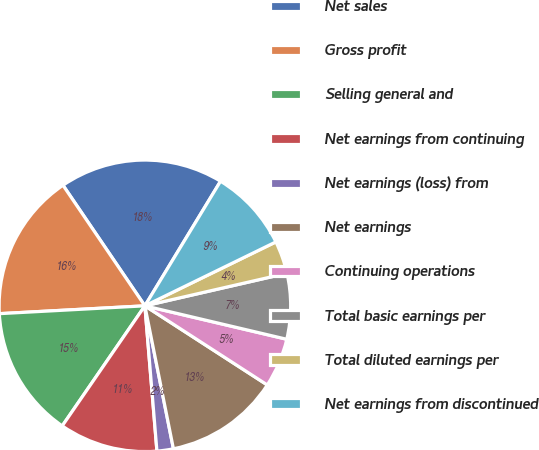<chart> <loc_0><loc_0><loc_500><loc_500><pie_chart><fcel>Net sales<fcel>Gross profit<fcel>Selling general and<fcel>Net earnings from continuing<fcel>Net earnings (loss) from<fcel>Net earnings<fcel>Continuing operations<fcel>Total basic earnings per<fcel>Total diluted earnings per<fcel>Net earnings from discontinued<nl><fcel>18.18%<fcel>16.36%<fcel>14.55%<fcel>10.91%<fcel>1.82%<fcel>12.73%<fcel>5.45%<fcel>7.27%<fcel>3.64%<fcel>9.09%<nl></chart> 